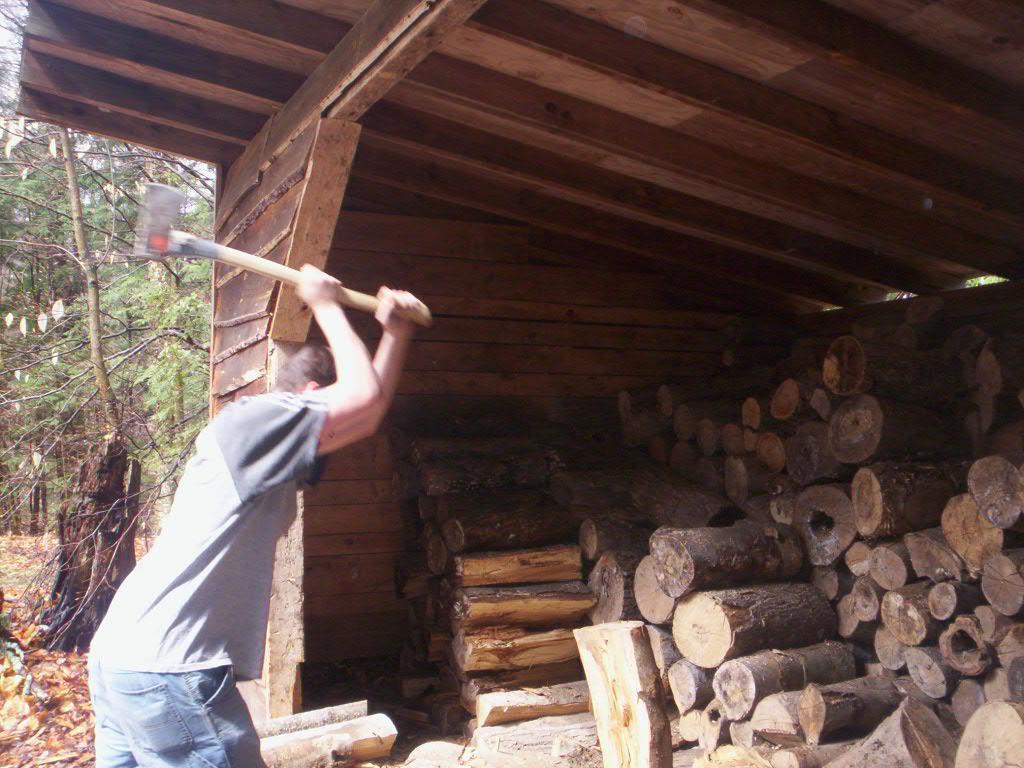Describe this image in one or two sentences. In the picture we can see a man standing and holding an ax and hitting a wood under the wooden shed and in the background we can see trees and dried leaves to the path. 